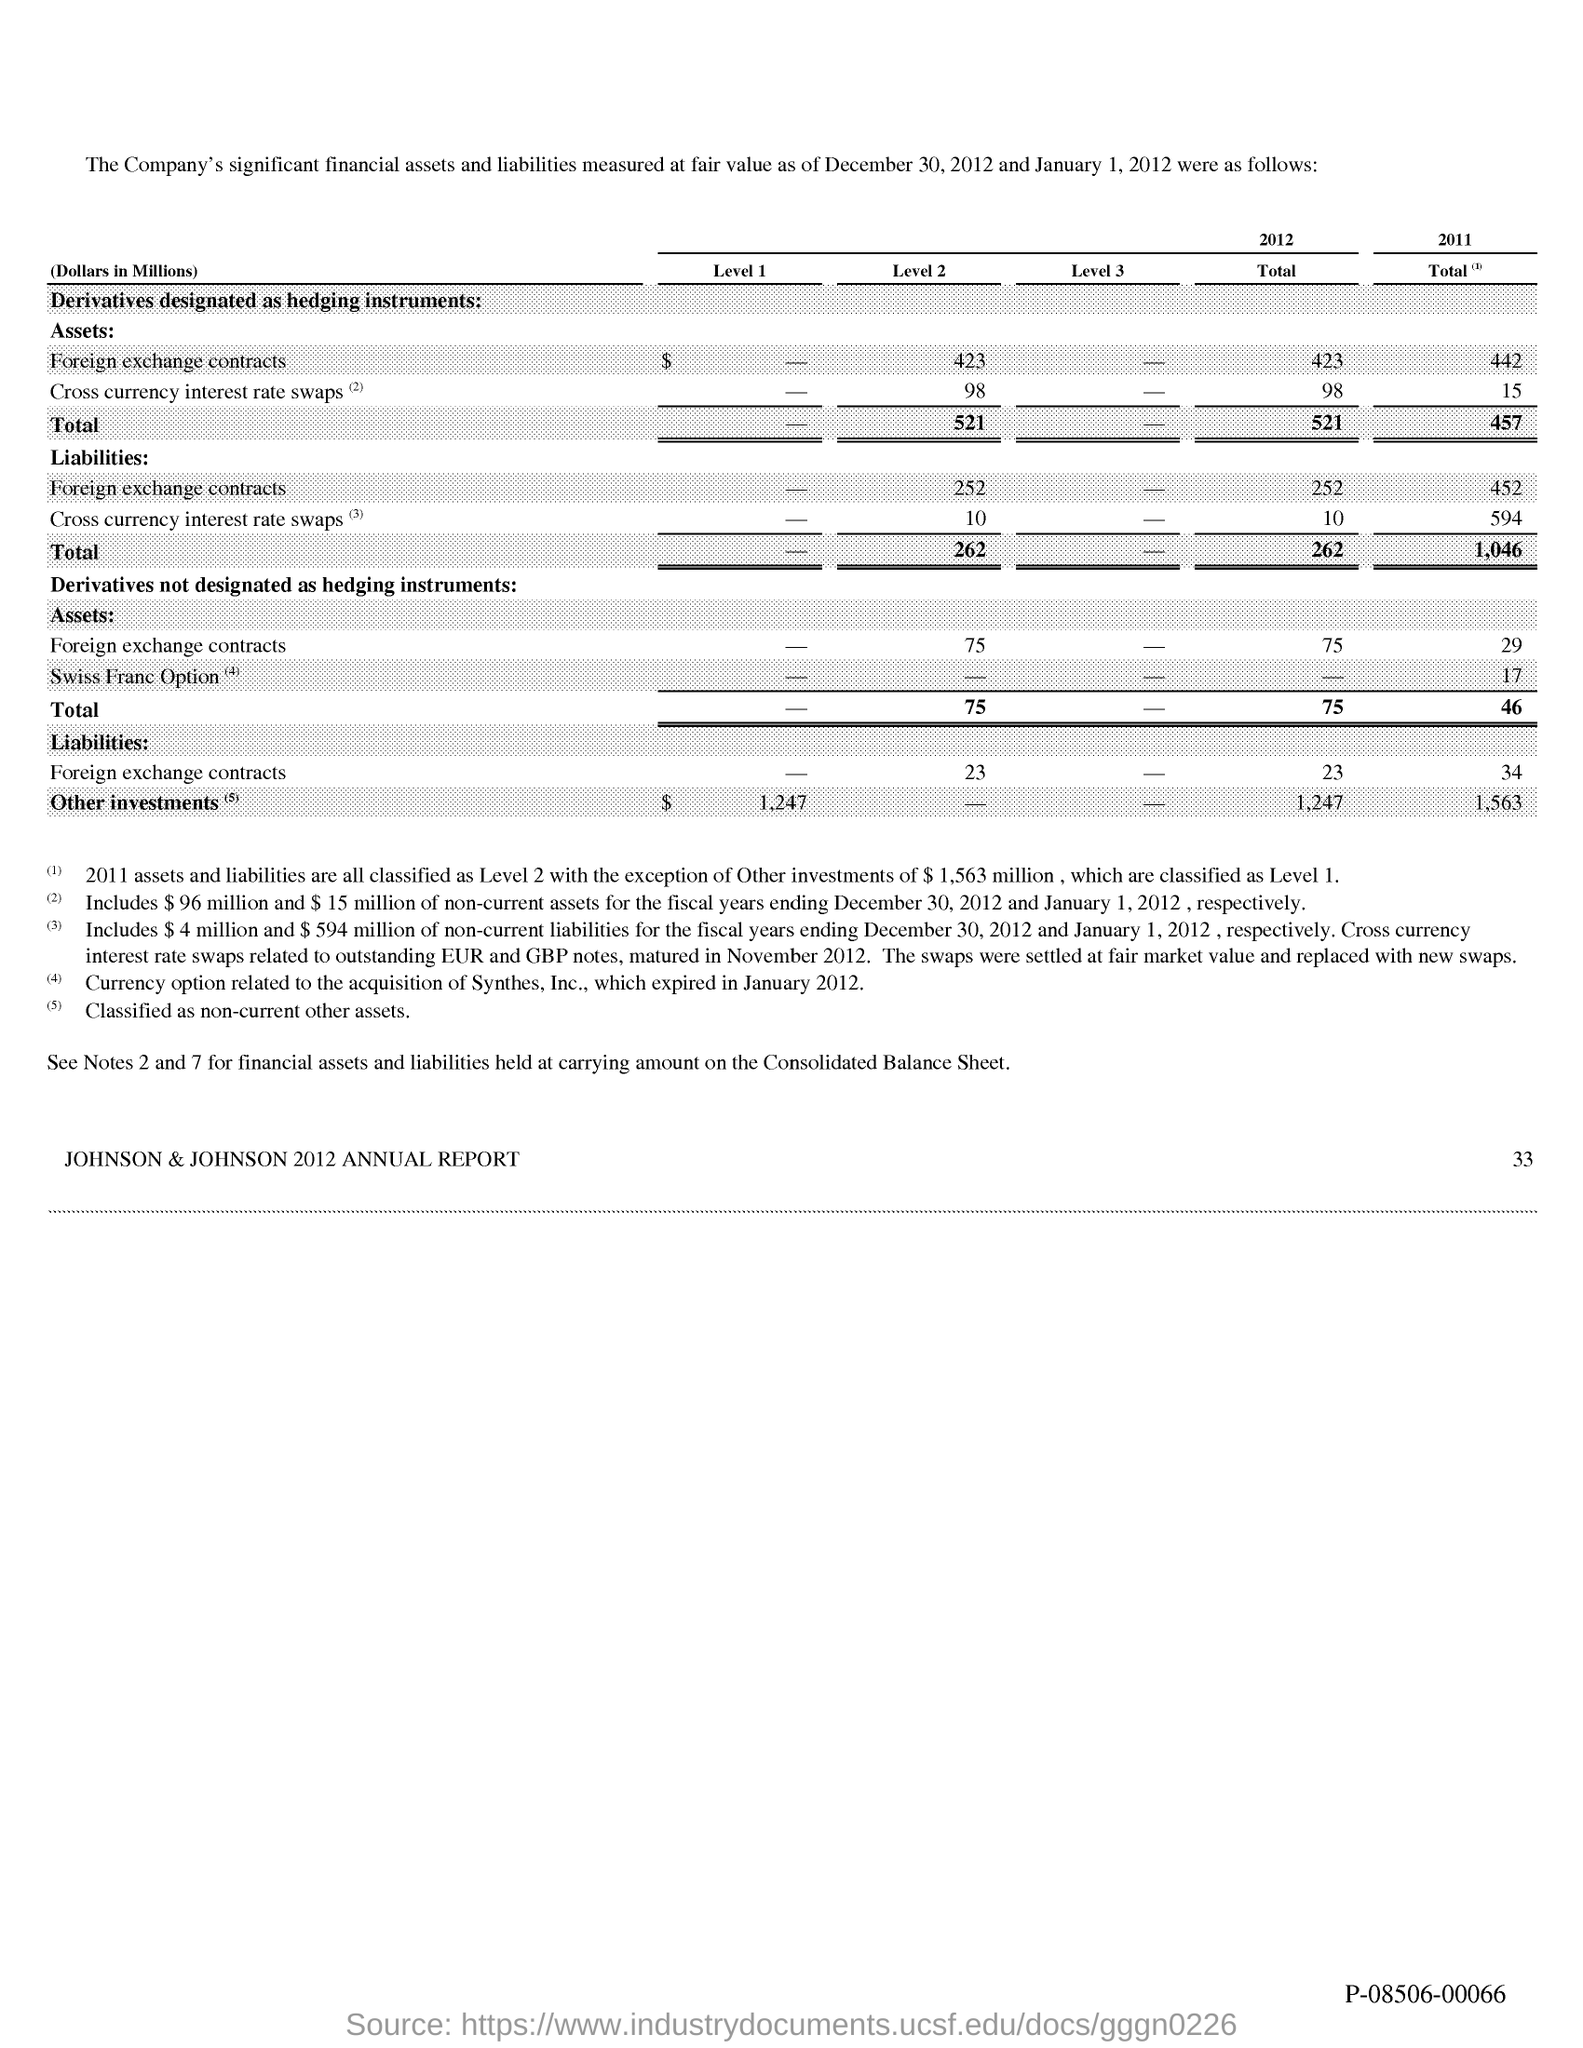Give some essential details in this illustration. The total liabilities for 2011 were 1,046. The total for Level 2 liabilities is $262. The total for 2012 liabilities is $262. 